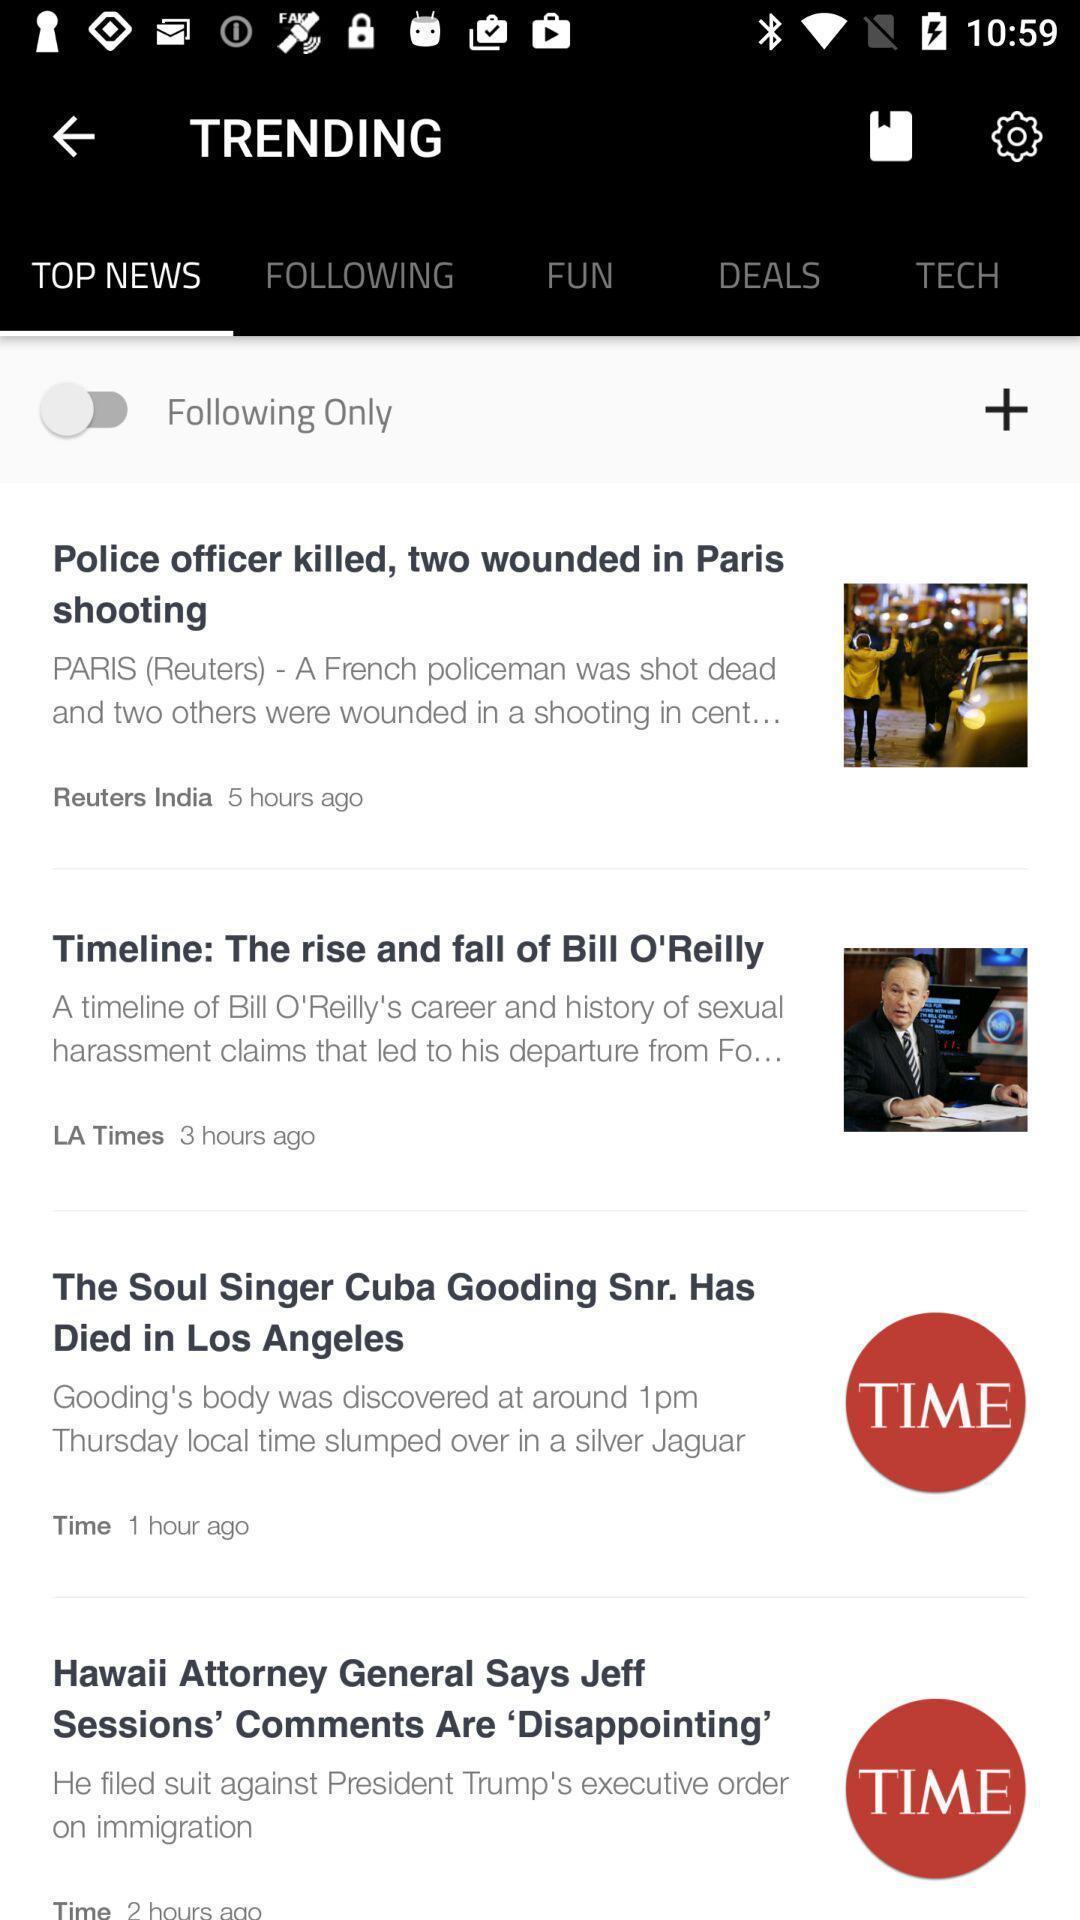Describe the key features of this screenshot. Screen displaying multiple latest news articles information. 